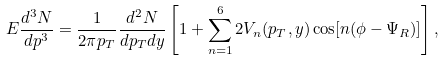Convert formula to latex. <formula><loc_0><loc_0><loc_500><loc_500>E \frac { d ^ { 3 } N } { d p ^ { 3 } } = \frac { 1 } { 2 \pi p _ { T } } \frac { d ^ { 2 } N } { d p _ { T } d y } \left [ 1 + \sum _ { n = 1 } ^ { 6 } 2 V _ { n } ( p _ { T } , y ) \cos [ n ( \phi - \Psi _ { R } ) ] \right ] ,</formula> 